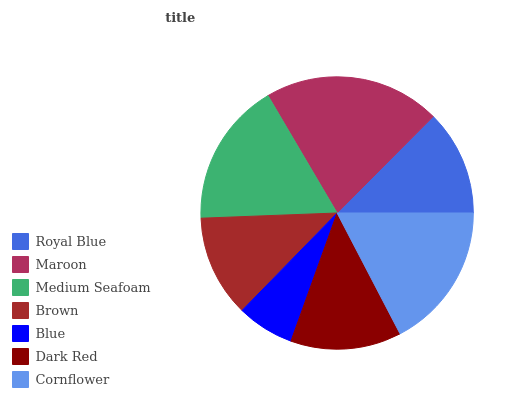Is Blue the minimum?
Answer yes or no. Yes. Is Maroon the maximum?
Answer yes or no. Yes. Is Medium Seafoam the minimum?
Answer yes or no. No. Is Medium Seafoam the maximum?
Answer yes or no. No. Is Maroon greater than Medium Seafoam?
Answer yes or no. Yes. Is Medium Seafoam less than Maroon?
Answer yes or no. Yes. Is Medium Seafoam greater than Maroon?
Answer yes or no. No. Is Maroon less than Medium Seafoam?
Answer yes or no. No. Is Dark Red the high median?
Answer yes or no. Yes. Is Dark Red the low median?
Answer yes or no. Yes. Is Maroon the high median?
Answer yes or no. No. Is Blue the low median?
Answer yes or no. No. 